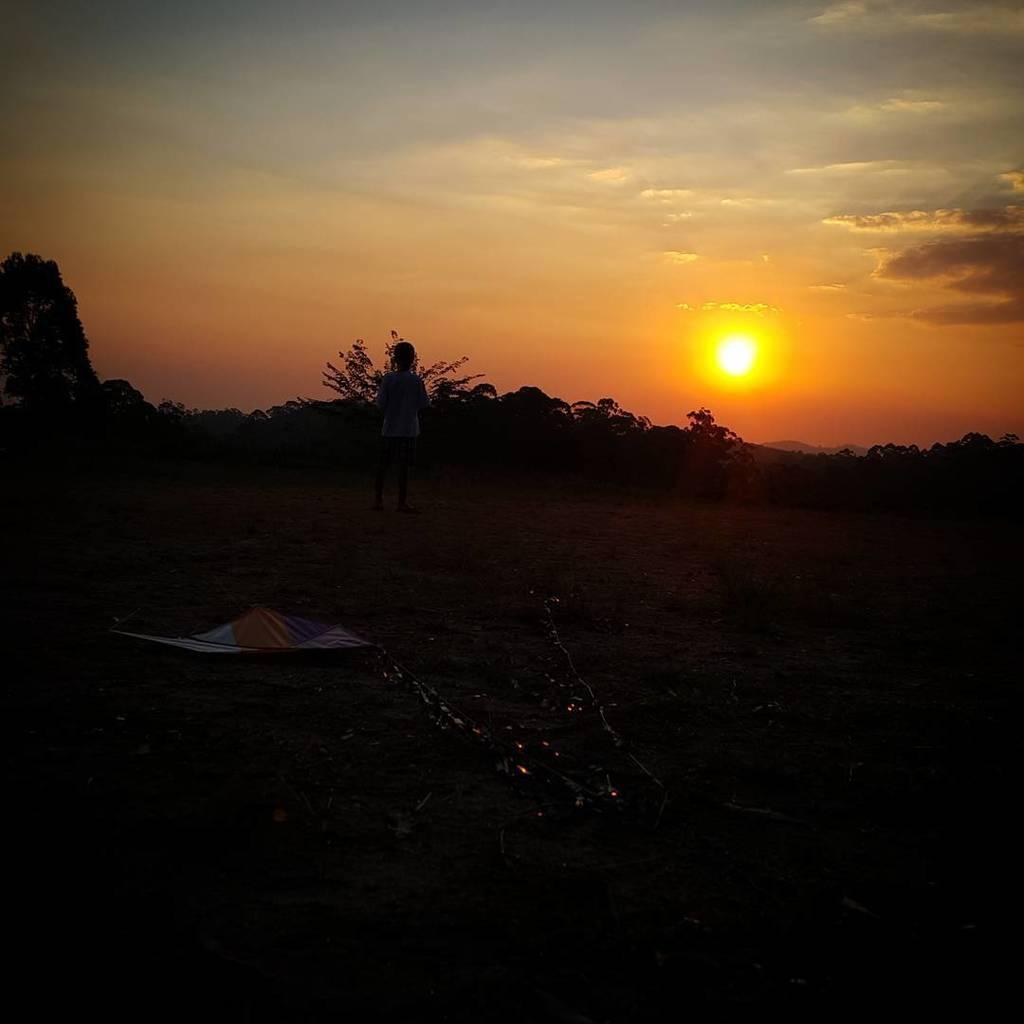In one or two sentences, can you explain what this image depicts? This part of the image is dark where we can see a person standing on the ground. Here we can see trees, the sun and the clouds in the sky. 